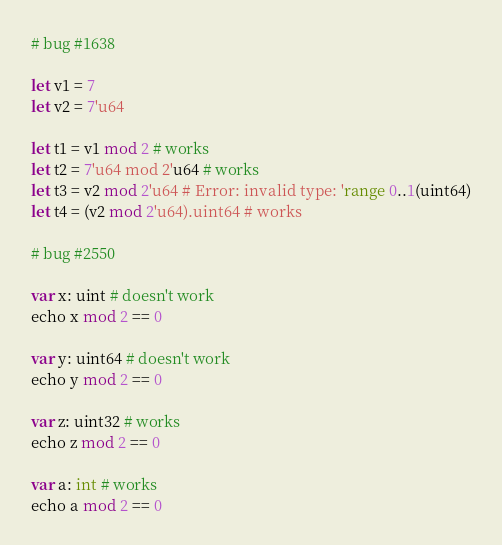<code> <loc_0><loc_0><loc_500><loc_500><_Nim_>
# bug #1638

let v1 = 7
let v2 = 7'u64

let t1 = v1 mod 2 # works
let t2 = 7'u64 mod 2'u64 # works
let t3 = v2 mod 2'u64 # Error: invalid type: 'range 0..1(uint64)
let t4 = (v2 mod 2'u64).uint64 # works

# bug #2550

var x: uint # doesn't work
echo x mod 2 == 0

var y: uint64 # doesn't work
echo y mod 2 == 0

var z: uint32 # works
echo z mod 2 == 0

var a: int # works
echo a mod 2 == 0
</code> 